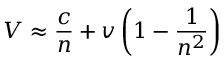Convert formula to latex. <formula><loc_0><loc_0><loc_500><loc_500>V \approx { \frac { c } { n } } + v \left ( 1 - { \frac { 1 } { n ^ { 2 } } } \right )</formula> 